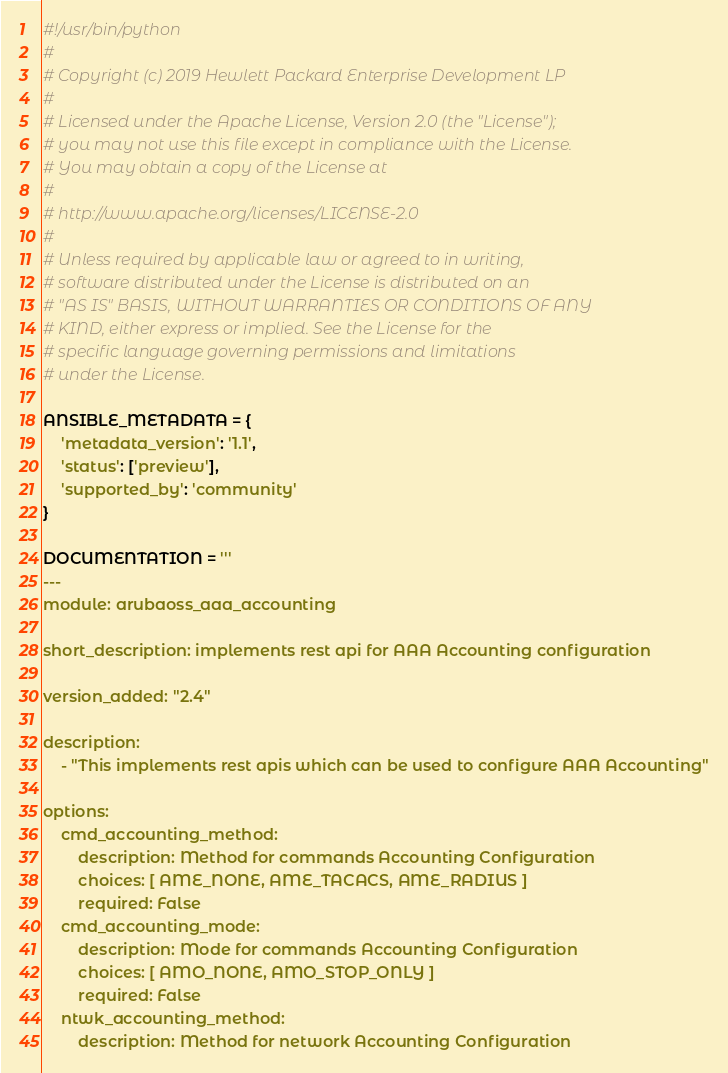<code> <loc_0><loc_0><loc_500><loc_500><_Python_>#!/usr/bin/python
#
# Copyright (c) 2019 Hewlett Packard Enterprise Development LP
#
# Licensed under the Apache License, Version 2.0 (the "License");
# you may not use this file except in compliance with the License.
# You may obtain a copy of the License at
#
# http://www.apache.org/licenses/LICENSE-2.0
#
# Unless required by applicable law or agreed to in writing,
# software distributed under the License is distributed on an
# "AS IS" BASIS, WITHOUT WARRANTIES OR CONDITIONS OF ANY
# KIND, either express or implied. See the License for the
# specific language governing permissions and limitations
# under the License.

ANSIBLE_METADATA = {
    'metadata_version': '1.1',
    'status': ['preview'],
    'supported_by': 'community'
}

DOCUMENTATION = '''
---
module: arubaoss_aaa_accounting

short_description: implements rest api for AAA Accounting configuration

version_added: "2.4"

description:
    - "This implements rest apis which can be used to configure AAA Accounting"

options:
    cmd_accounting_method:
        description: Method for commands Accounting Configuration
        choices: [ AME_NONE, AME_TACACS, AME_RADIUS ]
        required: False
    cmd_accounting_mode:
        description: Mode for commands Accounting Configuration
        choices: [ AMO_NONE, AMO_STOP_ONLY ]
        required: False
    ntwk_accounting_method:
        description: Method for network Accounting Configuration</code> 